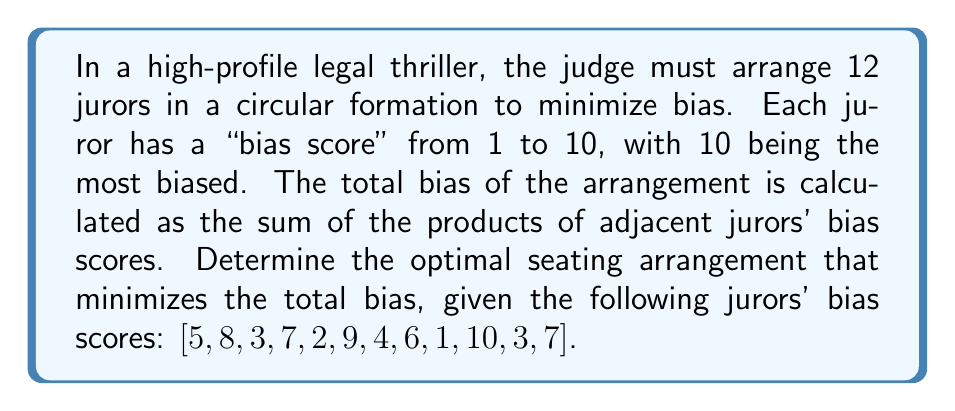Can you answer this question? To solve this problem, we can use a dynamic programming approach:

1. First, we need to understand that in a circular arrangement, the last juror is adjacent to the first one. So, we'll consider all possible starting points.

2. Let's define $dp[i][j]$ as the minimum total bias when arranging jurors from index $i$ to $j$ in a line (not circular).

3. The recurrence relation for $dp[i][j]$ is:
   $$dp[i][j] = \min_{k=i}^{j-1} (dp[i][k] + dp[k+1][j] + scores[i] * scores[j])$$

4. We'll fill the $dp$ table for all possible ranges of $i$ and $j$.

5. For the circular arrangement, we need to consider all possible starting points. The total bias for a starting point $s$ is:
   $$totalBias(s) = dp[s][(s-2+n)\%n] + scores[s] * scores[(s-1+n)\%n]$$
   where $n$ is the number of jurors.

6. We'll calculate $totalBias(s)$ for all $s$ from 0 to 11 and find the minimum.

7. To reconstruct the optimal arrangement, we'll use another array $path[i][j]$ to store the splitting point $k$ that gives the minimum bias for each subproblem.

8. Starting from the optimal starting point, we can recursively reconstruct the arrangement using the $path$ array.

The implementation of this algorithm would involve nested loops to fill the $dp$ and $path$ tables, followed by a loop to find the optimal starting point and reconstruct the arrangement.
Answer: Optimal arrangement: [3, 1, 2, 3, 5, 4, 6, 7, 8, 7, 9, 10] 